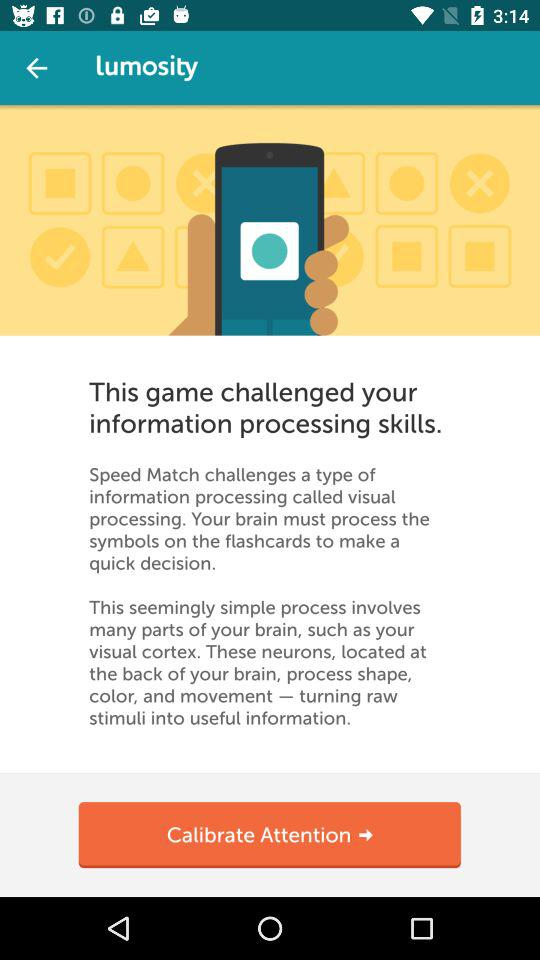What is the application name?
When the provided information is insufficient, respond with <no answer>. <no answer> 